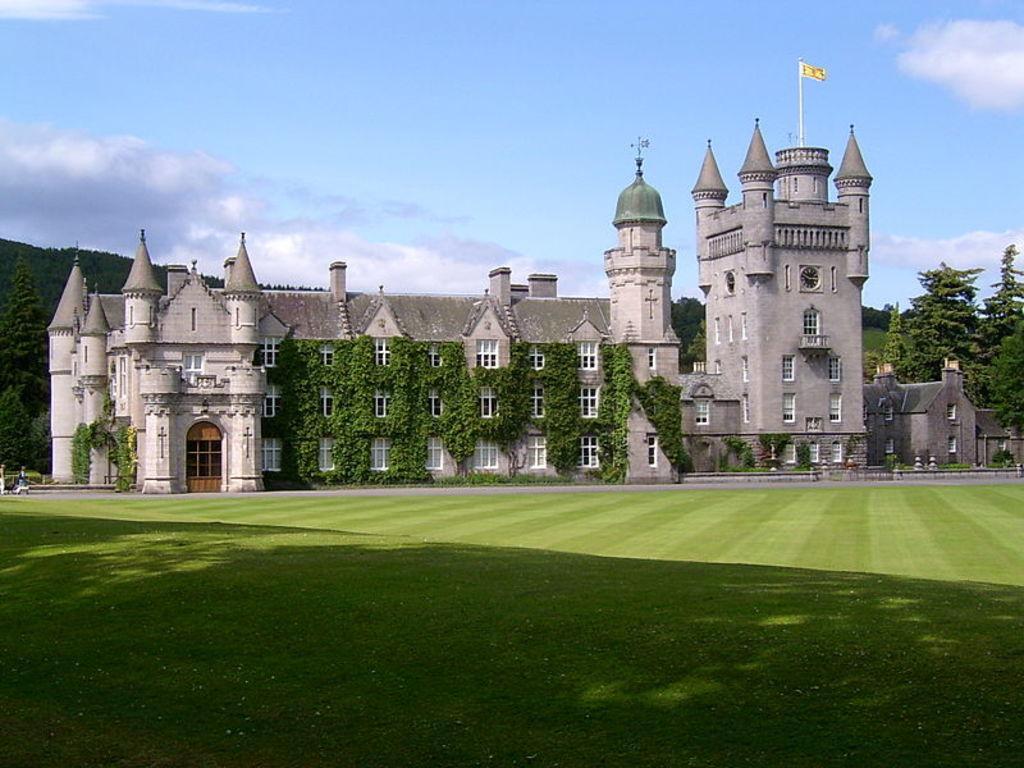How would you summarize this image in a sentence or two? In this image in the center there is a palace and some plants, and on the palace there is a pole and flag and at the bottom there is grass. And in the background there are some trees, at the top of the image there is sky. 